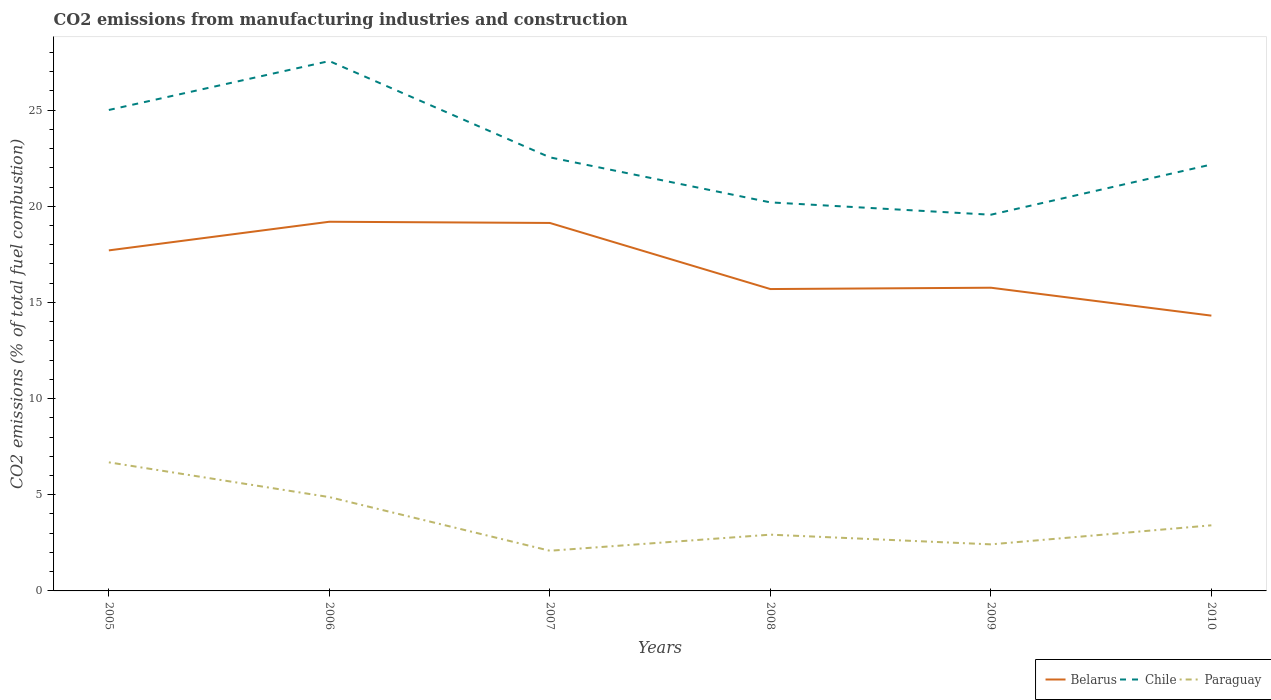Across all years, what is the maximum amount of CO2 emitted in Paraguay?
Provide a succinct answer. 2.09. In which year was the amount of CO2 emitted in Chile maximum?
Ensure brevity in your answer.  2009. What is the total amount of CO2 emitted in Paraguay in the graph?
Offer a terse response. 1.81. What is the difference between the highest and the second highest amount of CO2 emitted in Belarus?
Keep it short and to the point. 4.88. What is the difference between the highest and the lowest amount of CO2 emitted in Belarus?
Your response must be concise. 3. Is the amount of CO2 emitted in Chile strictly greater than the amount of CO2 emitted in Belarus over the years?
Your answer should be very brief. No. How many lines are there?
Make the answer very short. 3. How many years are there in the graph?
Keep it short and to the point. 6. Are the values on the major ticks of Y-axis written in scientific E-notation?
Make the answer very short. No. Does the graph contain any zero values?
Provide a succinct answer. No. What is the title of the graph?
Keep it short and to the point. CO2 emissions from manufacturing industries and construction. What is the label or title of the Y-axis?
Offer a terse response. CO2 emissions (% of total fuel combustion). What is the CO2 emissions (% of total fuel combustion) of Belarus in 2005?
Give a very brief answer. 17.71. What is the CO2 emissions (% of total fuel combustion) in Chile in 2005?
Your answer should be very brief. 25.01. What is the CO2 emissions (% of total fuel combustion) of Paraguay in 2005?
Your answer should be compact. 6.69. What is the CO2 emissions (% of total fuel combustion) in Belarus in 2006?
Offer a very short reply. 19.2. What is the CO2 emissions (% of total fuel combustion) in Chile in 2006?
Offer a very short reply. 27.55. What is the CO2 emissions (% of total fuel combustion) in Paraguay in 2006?
Keep it short and to the point. 4.88. What is the CO2 emissions (% of total fuel combustion) in Belarus in 2007?
Your answer should be very brief. 19.13. What is the CO2 emissions (% of total fuel combustion) in Chile in 2007?
Offer a very short reply. 22.55. What is the CO2 emissions (% of total fuel combustion) of Paraguay in 2007?
Offer a terse response. 2.09. What is the CO2 emissions (% of total fuel combustion) in Belarus in 2008?
Offer a very short reply. 15.7. What is the CO2 emissions (% of total fuel combustion) in Chile in 2008?
Provide a short and direct response. 20.2. What is the CO2 emissions (% of total fuel combustion) in Paraguay in 2008?
Your response must be concise. 2.93. What is the CO2 emissions (% of total fuel combustion) in Belarus in 2009?
Provide a short and direct response. 15.77. What is the CO2 emissions (% of total fuel combustion) in Chile in 2009?
Make the answer very short. 19.56. What is the CO2 emissions (% of total fuel combustion) of Paraguay in 2009?
Provide a short and direct response. 2.42. What is the CO2 emissions (% of total fuel combustion) of Belarus in 2010?
Make the answer very short. 14.31. What is the CO2 emissions (% of total fuel combustion) in Chile in 2010?
Provide a short and direct response. 22.17. What is the CO2 emissions (% of total fuel combustion) in Paraguay in 2010?
Make the answer very short. 3.41. Across all years, what is the maximum CO2 emissions (% of total fuel combustion) in Belarus?
Make the answer very short. 19.2. Across all years, what is the maximum CO2 emissions (% of total fuel combustion) in Chile?
Your response must be concise. 27.55. Across all years, what is the maximum CO2 emissions (% of total fuel combustion) in Paraguay?
Your answer should be very brief. 6.69. Across all years, what is the minimum CO2 emissions (% of total fuel combustion) in Belarus?
Offer a terse response. 14.31. Across all years, what is the minimum CO2 emissions (% of total fuel combustion) in Chile?
Make the answer very short. 19.56. Across all years, what is the minimum CO2 emissions (% of total fuel combustion) in Paraguay?
Give a very brief answer. 2.09. What is the total CO2 emissions (% of total fuel combustion) in Belarus in the graph?
Make the answer very short. 101.82. What is the total CO2 emissions (% of total fuel combustion) in Chile in the graph?
Provide a short and direct response. 137.04. What is the total CO2 emissions (% of total fuel combustion) of Paraguay in the graph?
Give a very brief answer. 22.41. What is the difference between the CO2 emissions (% of total fuel combustion) of Belarus in 2005 and that in 2006?
Provide a short and direct response. -1.49. What is the difference between the CO2 emissions (% of total fuel combustion) of Chile in 2005 and that in 2006?
Offer a terse response. -2.54. What is the difference between the CO2 emissions (% of total fuel combustion) of Paraguay in 2005 and that in 2006?
Give a very brief answer. 1.81. What is the difference between the CO2 emissions (% of total fuel combustion) of Belarus in 2005 and that in 2007?
Provide a short and direct response. -1.43. What is the difference between the CO2 emissions (% of total fuel combustion) of Chile in 2005 and that in 2007?
Offer a terse response. 2.46. What is the difference between the CO2 emissions (% of total fuel combustion) of Paraguay in 2005 and that in 2007?
Keep it short and to the point. 4.6. What is the difference between the CO2 emissions (% of total fuel combustion) of Belarus in 2005 and that in 2008?
Offer a very short reply. 2.01. What is the difference between the CO2 emissions (% of total fuel combustion) of Chile in 2005 and that in 2008?
Your answer should be very brief. 4.8. What is the difference between the CO2 emissions (% of total fuel combustion) of Paraguay in 2005 and that in 2008?
Give a very brief answer. 3.76. What is the difference between the CO2 emissions (% of total fuel combustion) of Belarus in 2005 and that in 2009?
Give a very brief answer. 1.94. What is the difference between the CO2 emissions (% of total fuel combustion) in Chile in 2005 and that in 2009?
Provide a succinct answer. 5.45. What is the difference between the CO2 emissions (% of total fuel combustion) in Paraguay in 2005 and that in 2009?
Your answer should be compact. 4.26. What is the difference between the CO2 emissions (% of total fuel combustion) in Belarus in 2005 and that in 2010?
Give a very brief answer. 3.39. What is the difference between the CO2 emissions (% of total fuel combustion) in Chile in 2005 and that in 2010?
Make the answer very short. 2.84. What is the difference between the CO2 emissions (% of total fuel combustion) of Paraguay in 2005 and that in 2010?
Your response must be concise. 3.27. What is the difference between the CO2 emissions (% of total fuel combustion) in Belarus in 2006 and that in 2007?
Keep it short and to the point. 0.06. What is the difference between the CO2 emissions (% of total fuel combustion) of Chile in 2006 and that in 2007?
Offer a terse response. 5.01. What is the difference between the CO2 emissions (% of total fuel combustion) of Paraguay in 2006 and that in 2007?
Your response must be concise. 2.79. What is the difference between the CO2 emissions (% of total fuel combustion) in Belarus in 2006 and that in 2008?
Ensure brevity in your answer.  3.5. What is the difference between the CO2 emissions (% of total fuel combustion) of Chile in 2006 and that in 2008?
Your answer should be compact. 7.35. What is the difference between the CO2 emissions (% of total fuel combustion) of Paraguay in 2006 and that in 2008?
Your response must be concise. 1.95. What is the difference between the CO2 emissions (% of total fuel combustion) of Belarus in 2006 and that in 2009?
Provide a succinct answer. 3.43. What is the difference between the CO2 emissions (% of total fuel combustion) in Chile in 2006 and that in 2009?
Keep it short and to the point. 7.99. What is the difference between the CO2 emissions (% of total fuel combustion) in Paraguay in 2006 and that in 2009?
Provide a succinct answer. 2.46. What is the difference between the CO2 emissions (% of total fuel combustion) of Belarus in 2006 and that in 2010?
Ensure brevity in your answer.  4.88. What is the difference between the CO2 emissions (% of total fuel combustion) of Chile in 2006 and that in 2010?
Offer a very short reply. 5.38. What is the difference between the CO2 emissions (% of total fuel combustion) in Paraguay in 2006 and that in 2010?
Provide a short and direct response. 1.47. What is the difference between the CO2 emissions (% of total fuel combustion) in Belarus in 2007 and that in 2008?
Offer a very short reply. 3.44. What is the difference between the CO2 emissions (% of total fuel combustion) in Chile in 2007 and that in 2008?
Offer a terse response. 2.34. What is the difference between the CO2 emissions (% of total fuel combustion) of Paraguay in 2007 and that in 2008?
Your answer should be very brief. -0.84. What is the difference between the CO2 emissions (% of total fuel combustion) of Belarus in 2007 and that in 2009?
Give a very brief answer. 3.37. What is the difference between the CO2 emissions (% of total fuel combustion) in Chile in 2007 and that in 2009?
Provide a short and direct response. 2.98. What is the difference between the CO2 emissions (% of total fuel combustion) of Paraguay in 2007 and that in 2009?
Your answer should be compact. -0.33. What is the difference between the CO2 emissions (% of total fuel combustion) in Belarus in 2007 and that in 2010?
Ensure brevity in your answer.  4.82. What is the difference between the CO2 emissions (% of total fuel combustion) in Chile in 2007 and that in 2010?
Offer a very short reply. 0.37. What is the difference between the CO2 emissions (% of total fuel combustion) in Paraguay in 2007 and that in 2010?
Offer a terse response. -1.32. What is the difference between the CO2 emissions (% of total fuel combustion) of Belarus in 2008 and that in 2009?
Give a very brief answer. -0.07. What is the difference between the CO2 emissions (% of total fuel combustion) in Chile in 2008 and that in 2009?
Offer a terse response. 0.64. What is the difference between the CO2 emissions (% of total fuel combustion) in Paraguay in 2008 and that in 2009?
Give a very brief answer. 0.5. What is the difference between the CO2 emissions (% of total fuel combustion) in Belarus in 2008 and that in 2010?
Your answer should be very brief. 1.38. What is the difference between the CO2 emissions (% of total fuel combustion) of Chile in 2008 and that in 2010?
Offer a terse response. -1.97. What is the difference between the CO2 emissions (% of total fuel combustion) of Paraguay in 2008 and that in 2010?
Give a very brief answer. -0.49. What is the difference between the CO2 emissions (% of total fuel combustion) of Belarus in 2009 and that in 2010?
Provide a succinct answer. 1.45. What is the difference between the CO2 emissions (% of total fuel combustion) of Chile in 2009 and that in 2010?
Keep it short and to the point. -2.61. What is the difference between the CO2 emissions (% of total fuel combustion) in Paraguay in 2009 and that in 2010?
Your response must be concise. -0.99. What is the difference between the CO2 emissions (% of total fuel combustion) of Belarus in 2005 and the CO2 emissions (% of total fuel combustion) of Chile in 2006?
Keep it short and to the point. -9.84. What is the difference between the CO2 emissions (% of total fuel combustion) of Belarus in 2005 and the CO2 emissions (% of total fuel combustion) of Paraguay in 2006?
Provide a succinct answer. 12.83. What is the difference between the CO2 emissions (% of total fuel combustion) in Chile in 2005 and the CO2 emissions (% of total fuel combustion) in Paraguay in 2006?
Your answer should be very brief. 20.13. What is the difference between the CO2 emissions (% of total fuel combustion) in Belarus in 2005 and the CO2 emissions (% of total fuel combustion) in Chile in 2007?
Give a very brief answer. -4.84. What is the difference between the CO2 emissions (% of total fuel combustion) in Belarus in 2005 and the CO2 emissions (% of total fuel combustion) in Paraguay in 2007?
Give a very brief answer. 15.62. What is the difference between the CO2 emissions (% of total fuel combustion) in Chile in 2005 and the CO2 emissions (% of total fuel combustion) in Paraguay in 2007?
Offer a very short reply. 22.92. What is the difference between the CO2 emissions (% of total fuel combustion) in Belarus in 2005 and the CO2 emissions (% of total fuel combustion) in Chile in 2008?
Keep it short and to the point. -2.5. What is the difference between the CO2 emissions (% of total fuel combustion) in Belarus in 2005 and the CO2 emissions (% of total fuel combustion) in Paraguay in 2008?
Your answer should be very brief. 14.78. What is the difference between the CO2 emissions (% of total fuel combustion) of Chile in 2005 and the CO2 emissions (% of total fuel combustion) of Paraguay in 2008?
Provide a short and direct response. 22.08. What is the difference between the CO2 emissions (% of total fuel combustion) in Belarus in 2005 and the CO2 emissions (% of total fuel combustion) in Chile in 2009?
Make the answer very short. -1.85. What is the difference between the CO2 emissions (% of total fuel combustion) in Belarus in 2005 and the CO2 emissions (% of total fuel combustion) in Paraguay in 2009?
Your response must be concise. 15.29. What is the difference between the CO2 emissions (% of total fuel combustion) in Chile in 2005 and the CO2 emissions (% of total fuel combustion) in Paraguay in 2009?
Provide a succinct answer. 22.59. What is the difference between the CO2 emissions (% of total fuel combustion) in Belarus in 2005 and the CO2 emissions (% of total fuel combustion) in Chile in 2010?
Give a very brief answer. -4.46. What is the difference between the CO2 emissions (% of total fuel combustion) of Belarus in 2005 and the CO2 emissions (% of total fuel combustion) of Paraguay in 2010?
Make the answer very short. 14.3. What is the difference between the CO2 emissions (% of total fuel combustion) in Chile in 2005 and the CO2 emissions (% of total fuel combustion) in Paraguay in 2010?
Your response must be concise. 21.6. What is the difference between the CO2 emissions (% of total fuel combustion) in Belarus in 2006 and the CO2 emissions (% of total fuel combustion) in Chile in 2007?
Your answer should be very brief. -3.35. What is the difference between the CO2 emissions (% of total fuel combustion) in Belarus in 2006 and the CO2 emissions (% of total fuel combustion) in Paraguay in 2007?
Make the answer very short. 17.11. What is the difference between the CO2 emissions (% of total fuel combustion) in Chile in 2006 and the CO2 emissions (% of total fuel combustion) in Paraguay in 2007?
Your answer should be very brief. 25.46. What is the difference between the CO2 emissions (% of total fuel combustion) of Belarus in 2006 and the CO2 emissions (% of total fuel combustion) of Chile in 2008?
Ensure brevity in your answer.  -1.01. What is the difference between the CO2 emissions (% of total fuel combustion) of Belarus in 2006 and the CO2 emissions (% of total fuel combustion) of Paraguay in 2008?
Provide a short and direct response. 16.27. What is the difference between the CO2 emissions (% of total fuel combustion) in Chile in 2006 and the CO2 emissions (% of total fuel combustion) in Paraguay in 2008?
Your answer should be compact. 24.63. What is the difference between the CO2 emissions (% of total fuel combustion) in Belarus in 2006 and the CO2 emissions (% of total fuel combustion) in Chile in 2009?
Your answer should be very brief. -0.37. What is the difference between the CO2 emissions (% of total fuel combustion) in Belarus in 2006 and the CO2 emissions (% of total fuel combustion) in Paraguay in 2009?
Make the answer very short. 16.78. What is the difference between the CO2 emissions (% of total fuel combustion) in Chile in 2006 and the CO2 emissions (% of total fuel combustion) in Paraguay in 2009?
Ensure brevity in your answer.  25.13. What is the difference between the CO2 emissions (% of total fuel combustion) of Belarus in 2006 and the CO2 emissions (% of total fuel combustion) of Chile in 2010?
Offer a very short reply. -2.98. What is the difference between the CO2 emissions (% of total fuel combustion) in Belarus in 2006 and the CO2 emissions (% of total fuel combustion) in Paraguay in 2010?
Your answer should be compact. 15.79. What is the difference between the CO2 emissions (% of total fuel combustion) in Chile in 2006 and the CO2 emissions (% of total fuel combustion) in Paraguay in 2010?
Offer a very short reply. 24.14. What is the difference between the CO2 emissions (% of total fuel combustion) in Belarus in 2007 and the CO2 emissions (% of total fuel combustion) in Chile in 2008?
Offer a very short reply. -1.07. What is the difference between the CO2 emissions (% of total fuel combustion) of Belarus in 2007 and the CO2 emissions (% of total fuel combustion) of Paraguay in 2008?
Your answer should be very brief. 16.21. What is the difference between the CO2 emissions (% of total fuel combustion) in Chile in 2007 and the CO2 emissions (% of total fuel combustion) in Paraguay in 2008?
Offer a very short reply. 19.62. What is the difference between the CO2 emissions (% of total fuel combustion) of Belarus in 2007 and the CO2 emissions (% of total fuel combustion) of Chile in 2009?
Keep it short and to the point. -0.43. What is the difference between the CO2 emissions (% of total fuel combustion) in Belarus in 2007 and the CO2 emissions (% of total fuel combustion) in Paraguay in 2009?
Your answer should be compact. 16.71. What is the difference between the CO2 emissions (% of total fuel combustion) in Chile in 2007 and the CO2 emissions (% of total fuel combustion) in Paraguay in 2009?
Ensure brevity in your answer.  20.12. What is the difference between the CO2 emissions (% of total fuel combustion) of Belarus in 2007 and the CO2 emissions (% of total fuel combustion) of Chile in 2010?
Ensure brevity in your answer.  -3.04. What is the difference between the CO2 emissions (% of total fuel combustion) in Belarus in 2007 and the CO2 emissions (% of total fuel combustion) in Paraguay in 2010?
Provide a short and direct response. 15.72. What is the difference between the CO2 emissions (% of total fuel combustion) of Chile in 2007 and the CO2 emissions (% of total fuel combustion) of Paraguay in 2010?
Ensure brevity in your answer.  19.13. What is the difference between the CO2 emissions (% of total fuel combustion) of Belarus in 2008 and the CO2 emissions (% of total fuel combustion) of Chile in 2009?
Ensure brevity in your answer.  -3.86. What is the difference between the CO2 emissions (% of total fuel combustion) of Belarus in 2008 and the CO2 emissions (% of total fuel combustion) of Paraguay in 2009?
Your answer should be very brief. 13.28. What is the difference between the CO2 emissions (% of total fuel combustion) in Chile in 2008 and the CO2 emissions (% of total fuel combustion) in Paraguay in 2009?
Ensure brevity in your answer.  17.78. What is the difference between the CO2 emissions (% of total fuel combustion) in Belarus in 2008 and the CO2 emissions (% of total fuel combustion) in Chile in 2010?
Your response must be concise. -6.48. What is the difference between the CO2 emissions (% of total fuel combustion) of Belarus in 2008 and the CO2 emissions (% of total fuel combustion) of Paraguay in 2010?
Give a very brief answer. 12.29. What is the difference between the CO2 emissions (% of total fuel combustion) of Chile in 2008 and the CO2 emissions (% of total fuel combustion) of Paraguay in 2010?
Ensure brevity in your answer.  16.79. What is the difference between the CO2 emissions (% of total fuel combustion) of Belarus in 2009 and the CO2 emissions (% of total fuel combustion) of Chile in 2010?
Make the answer very short. -6.41. What is the difference between the CO2 emissions (% of total fuel combustion) of Belarus in 2009 and the CO2 emissions (% of total fuel combustion) of Paraguay in 2010?
Provide a succinct answer. 12.35. What is the difference between the CO2 emissions (% of total fuel combustion) in Chile in 2009 and the CO2 emissions (% of total fuel combustion) in Paraguay in 2010?
Your answer should be compact. 16.15. What is the average CO2 emissions (% of total fuel combustion) of Belarus per year?
Your answer should be compact. 16.97. What is the average CO2 emissions (% of total fuel combustion) of Chile per year?
Make the answer very short. 22.84. What is the average CO2 emissions (% of total fuel combustion) in Paraguay per year?
Offer a very short reply. 3.74. In the year 2005, what is the difference between the CO2 emissions (% of total fuel combustion) in Belarus and CO2 emissions (% of total fuel combustion) in Chile?
Your response must be concise. -7.3. In the year 2005, what is the difference between the CO2 emissions (% of total fuel combustion) of Belarus and CO2 emissions (% of total fuel combustion) of Paraguay?
Offer a terse response. 11.02. In the year 2005, what is the difference between the CO2 emissions (% of total fuel combustion) in Chile and CO2 emissions (% of total fuel combustion) in Paraguay?
Your response must be concise. 18.32. In the year 2006, what is the difference between the CO2 emissions (% of total fuel combustion) of Belarus and CO2 emissions (% of total fuel combustion) of Chile?
Make the answer very short. -8.36. In the year 2006, what is the difference between the CO2 emissions (% of total fuel combustion) of Belarus and CO2 emissions (% of total fuel combustion) of Paraguay?
Keep it short and to the point. 14.32. In the year 2006, what is the difference between the CO2 emissions (% of total fuel combustion) of Chile and CO2 emissions (% of total fuel combustion) of Paraguay?
Provide a short and direct response. 22.67. In the year 2007, what is the difference between the CO2 emissions (% of total fuel combustion) in Belarus and CO2 emissions (% of total fuel combustion) in Chile?
Offer a terse response. -3.41. In the year 2007, what is the difference between the CO2 emissions (% of total fuel combustion) in Belarus and CO2 emissions (% of total fuel combustion) in Paraguay?
Ensure brevity in your answer.  17.05. In the year 2007, what is the difference between the CO2 emissions (% of total fuel combustion) in Chile and CO2 emissions (% of total fuel combustion) in Paraguay?
Keep it short and to the point. 20.46. In the year 2008, what is the difference between the CO2 emissions (% of total fuel combustion) in Belarus and CO2 emissions (% of total fuel combustion) in Chile?
Keep it short and to the point. -4.51. In the year 2008, what is the difference between the CO2 emissions (% of total fuel combustion) in Belarus and CO2 emissions (% of total fuel combustion) in Paraguay?
Offer a terse response. 12.77. In the year 2008, what is the difference between the CO2 emissions (% of total fuel combustion) in Chile and CO2 emissions (% of total fuel combustion) in Paraguay?
Give a very brief answer. 17.28. In the year 2009, what is the difference between the CO2 emissions (% of total fuel combustion) in Belarus and CO2 emissions (% of total fuel combustion) in Chile?
Provide a succinct answer. -3.8. In the year 2009, what is the difference between the CO2 emissions (% of total fuel combustion) in Belarus and CO2 emissions (% of total fuel combustion) in Paraguay?
Provide a short and direct response. 13.35. In the year 2009, what is the difference between the CO2 emissions (% of total fuel combustion) of Chile and CO2 emissions (% of total fuel combustion) of Paraguay?
Your answer should be very brief. 17.14. In the year 2010, what is the difference between the CO2 emissions (% of total fuel combustion) of Belarus and CO2 emissions (% of total fuel combustion) of Chile?
Keep it short and to the point. -7.86. In the year 2010, what is the difference between the CO2 emissions (% of total fuel combustion) of Belarus and CO2 emissions (% of total fuel combustion) of Paraguay?
Your answer should be very brief. 10.9. In the year 2010, what is the difference between the CO2 emissions (% of total fuel combustion) of Chile and CO2 emissions (% of total fuel combustion) of Paraguay?
Your answer should be compact. 18.76. What is the ratio of the CO2 emissions (% of total fuel combustion) in Belarus in 2005 to that in 2006?
Provide a short and direct response. 0.92. What is the ratio of the CO2 emissions (% of total fuel combustion) of Chile in 2005 to that in 2006?
Offer a very short reply. 0.91. What is the ratio of the CO2 emissions (% of total fuel combustion) of Paraguay in 2005 to that in 2006?
Offer a terse response. 1.37. What is the ratio of the CO2 emissions (% of total fuel combustion) of Belarus in 2005 to that in 2007?
Keep it short and to the point. 0.93. What is the ratio of the CO2 emissions (% of total fuel combustion) of Chile in 2005 to that in 2007?
Offer a very short reply. 1.11. What is the ratio of the CO2 emissions (% of total fuel combustion) in Paraguay in 2005 to that in 2007?
Your answer should be very brief. 3.2. What is the ratio of the CO2 emissions (% of total fuel combustion) of Belarus in 2005 to that in 2008?
Provide a short and direct response. 1.13. What is the ratio of the CO2 emissions (% of total fuel combustion) in Chile in 2005 to that in 2008?
Your answer should be compact. 1.24. What is the ratio of the CO2 emissions (% of total fuel combustion) in Paraguay in 2005 to that in 2008?
Provide a short and direct response. 2.29. What is the ratio of the CO2 emissions (% of total fuel combustion) of Belarus in 2005 to that in 2009?
Provide a short and direct response. 1.12. What is the ratio of the CO2 emissions (% of total fuel combustion) in Chile in 2005 to that in 2009?
Your answer should be compact. 1.28. What is the ratio of the CO2 emissions (% of total fuel combustion) of Paraguay in 2005 to that in 2009?
Your response must be concise. 2.76. What is the ratio of the CO2 emissions (% of total fuel combustion) in Belarus in 2005 to that in 2010?
Your answer should be compact. 1.24. What is the ratio of the CO2 emissions (% of total fuel combustion) of Chile in 2005 to that in 2010?
Provide a short and direct response. 1.13. What is the ratio of the CO2 emissions (% of total fuel combustion) in Paraguay in 2005 to that in 2010?
Your answer should be compact. 1.96. What is the ratio of the CO2 emissions (% of total fuel combustion) in Chile in 2006 to that in 2007?
Offer a terse response. 1.22. What is the ratio of the CO2 emissions (% of total fuel combustion) of Paraguay in 2006 to that in 2007?
Your answer should be compact. 2.34. What is the ratio of the CO2 emissions (% of total fuel combustion) in Belarus in 2006 to that in 2008?
Keep it short and to the point. 1.22. What is the ratio of the CO2 emissions (% of total fuel combustion) of Chile in 2006 to that in 2008?
Your answer should be compact. 1.36. What is the ratio of the CO2 emissions (% of total fuel combustion) in Paraguay in 2006 to that in 2008?
Your answer should be compact. 1.67. What is the ratio of the CO2 emissions (% of total fuel combustion) of Belarus in 2006 to that in 2009?
Provide a short and direct response. 1.22. What is the ratio of the CO2 emissions (% of total fuel combustion) of Chile in 2006 to that in 2009?
Ensure brevity in your answer.  1.41. What is the ratio of the CO2 emissions (% of total fuel combustion) in Paraguay in 2006 to that in 2009?
Provide a short and direct response. 2.01. What is the ratio of the CO2 emissions (% of total fuel combustion) in Belarus in 2006 to that in 2010?
Offer a terse response. 1.34. What is the ratio of the CO2 emissions (% of total fuel combustion) in Chile in 2006 to that in 2010?
Your answer should be very brief. 1.24. What is the ratio of the CO2 emissions (% of total fuel combustion) in Paraguay in 2006 to that in 2010?
Give a very brief answer. 1.43. What is the ratio of the CO2 emissions (% of total fuel combustion) in Belarus in 2007 to that in 2008?
Provide a succinct answer. 1.22. What is the ratio of the CO2 emissions (% of total fuel combustion) in Chile in 2007 to that in 2008?
Ensure brevity in your answer.  1.12. What is the ratio of the CO2 emissions (% of total fuel combustion) of Paraguay in 2007 to that in 2008?
Provide a short and direct response. 0.71. What is the ratio of the CO2 emissions (% of total fuel combustion) in Belarus in 2007 to that in 2009?
Your response must be concise. 1.21. What is the ratio of the CO2 emissions (% of total fuel combustion) in Chile in 2007 to that in 2009?
Give a very brief answer. 1.15. What is the ratio of the CO2 emissions (% of total fuel combustion) of Paraguay in 2007 to that in 2009?
Your answer should be compact. 0.86. What is the ratio of the CO2 emissions (% of total fuel combustion) in Belarus in 2007 to that in 2010?
Offer a terse response. 1.34. What is the ratio of the CO2 emissions (% of total fuel combustion) of Chile in 2007 to that in 2010?
Your answer should be very brief. 1.02. What is the ratio of the CO2 emissions (% of total fuel combustion) of Paraguay in 2007 to that in 2010?
Keep it short and to the point. 0.61. What is the ratio of the CO2 emissions (% of total fuel combustion) in Belarus in 2008 to that in 2009?
Your answer should be compact. 1. What is the ratio of the CO2 emissions (% of total fuel combustion) in Chile in 2008 to that in 2009?
Offer a terse response. 1.03. What is the ratio of the CO2 emissions (% of total fuel combustion) in Paraguay in 2008 to that in 2009?
Offer a very short reply. 1.21. What is the ratio of the CO2 emissions (% of total fuel combustion) of Belarus in 2008 to that in 2010?
Keep it short and to the point. 1.1. What is the ratio of the CO2 emissions (% of total fuel combustion) of Chile in 2008 to that in 2010?
Your response must be concise. 0.91. What is the ratio of the CO2 emissions (% of total fuel combustion) in Paraguay in 2008 to that in 2010?
Your response must be concise. 0.86. What is the ratio of the CO2 emissions (% of total fuel combustion) of Belarus in 2009 to that in 2010?
Give a very brief answer. 1.1. What is the ratio of the CO2 emissions (% of total fuel combustion) in Chile in 2009 to that in 2010?
Make the answer very short. 0.88. What is the ratio of the CO2 emissions (% of total fuel combustion) of Paraguay in 2009 to that in 2010?
Your answer should be compact. 0.71. What is the difference between the highest and the second highest CO2 emissions (% of total fuel combustion) in Belarus?
Ensure brevity in your answer.  0.06. What is the difference between the highest and the second highest CO2 emissions (% of total fuel combustion) in Chile?
Your answer should be compact. 2.54. What is the difference between the highest and the second highest CO2 emissions (% of total fuel combustion) of Paraguay?
Offer a very short reply. 1.81. What is the difference between the highest and the lowest CO2 emissions (% of total fuel combustion) in Belarus?
Give a very brief answer. 4.88. What is the difference between the highest and the lowest CO2 emissions (% of total fuel combustion) in Chile?
Offer a very short reply. 7.99. What is the difference between the highest and the lowest CO2 emissions (% of total fuel combustion) of Paraguay?
Ensure brevity in your answer.  4.6. 